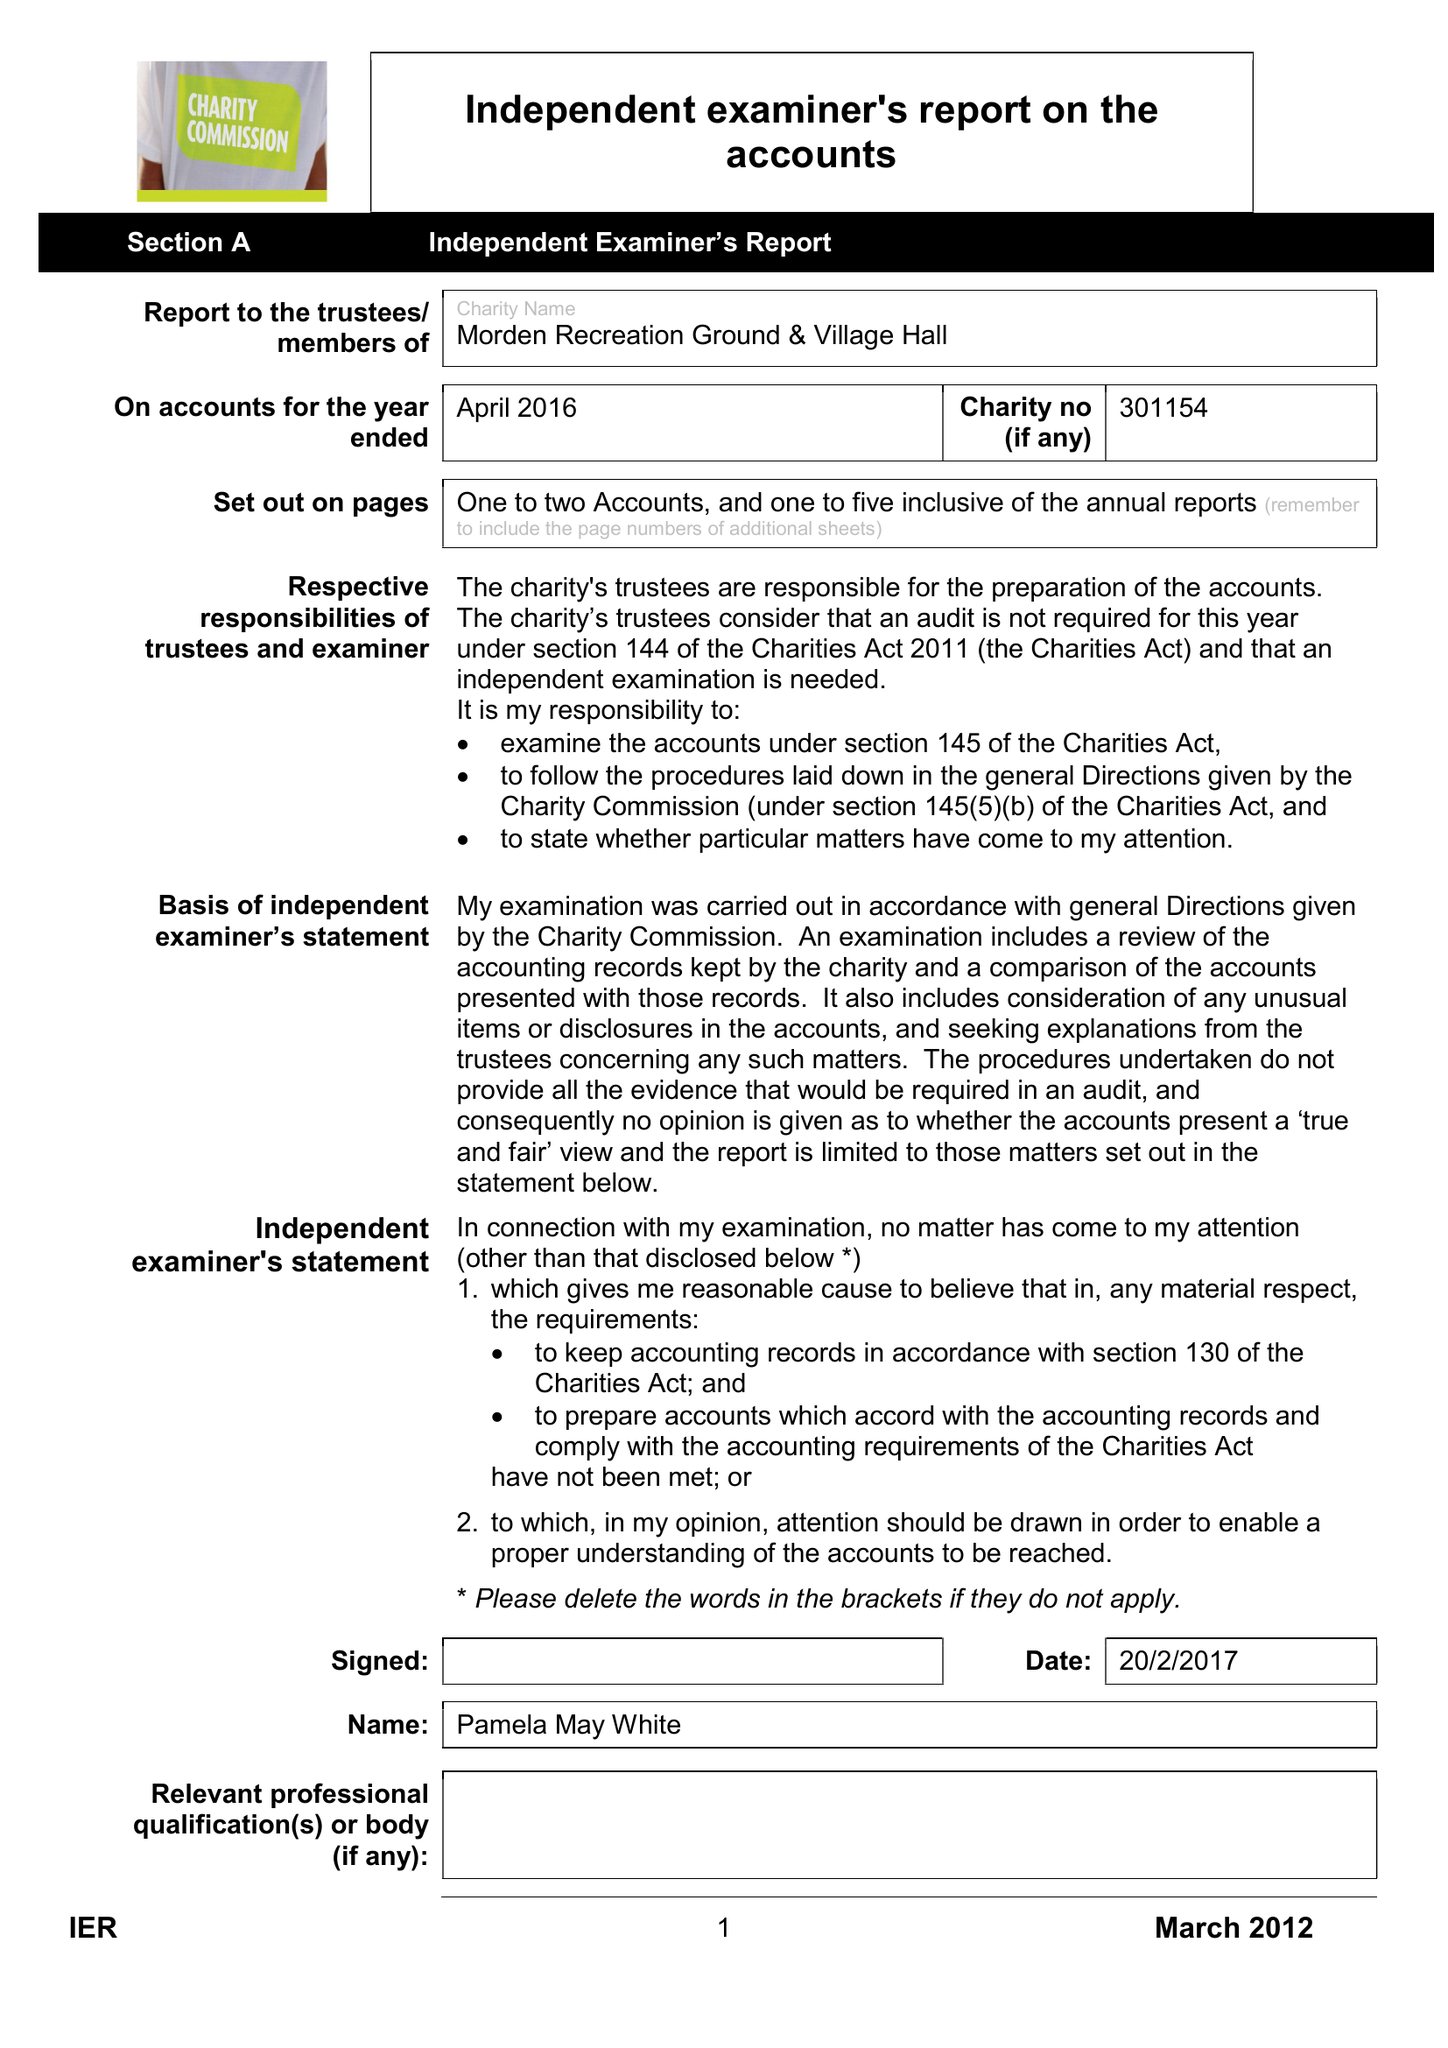What is the value for the income_annually_in_british_pounds?
Answer the question using a single word or phrase. 26455.00 